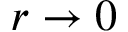<formula> <loc_0><loc_0><loc_500><loc_500>r \to 0</formula> 